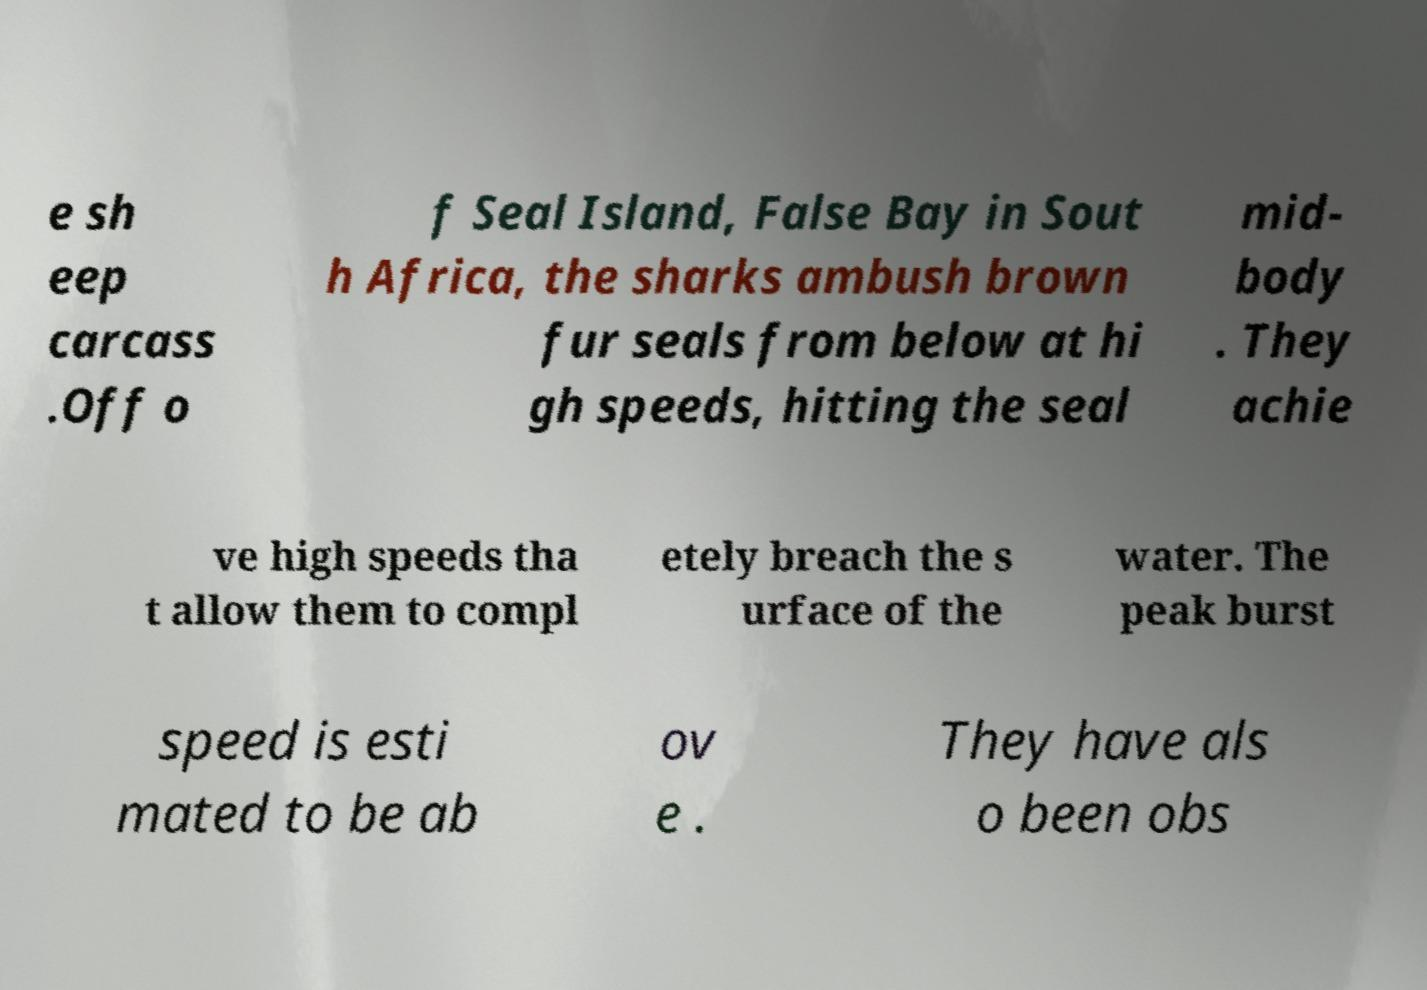I need the written content from this picture converted into text. Can you do that? e sh eep carcass .Off o f Seal Island, False Bay in Sout h Africa, the sharks ambush brown fur seals from below at hi gh speeds, hitting the seal mid- body . They achie ve high speeds tha t allow them to compl etely breach the s urface of the water. The peak burst speed is esti mated to be ab ov e . They have als o been obs 